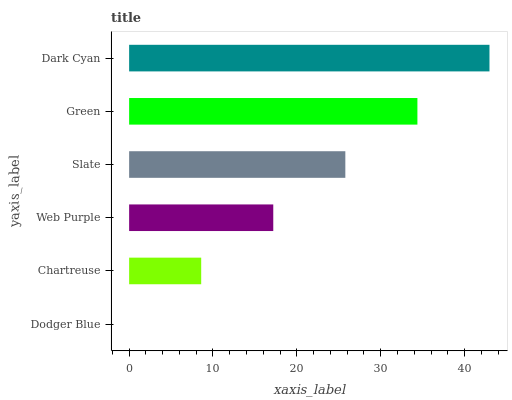Is Dodger Blue the minimum?
Answer yes or no. Yes. Is Dark Cyan the maximum?
Answer yes or no. Yes. Is Chartreuse the minimum?
Answer yes or no. No. Is Chartreuse the maximum?
Answer yes or no. No. Is Chartreuse greater than Dodger Blue?
Answer yes or no. Yes. Is Dodger Blue less than Chartreuse?
Answer yes or no. Yes. Is Dodger Blue greater than Chartreuse?
Answer yes or no. No. Is Chartreuse less than Dodger Blue?
Answer yes or no. No. Is Slate the high median?
Answer yes or no. Yes. Is Web Purple the low median?
Answer yes or no. Yes. Is Dark Cyan the high median?
Answer yes or no. No. Is Green the low median?
Answer yes or no. No. 